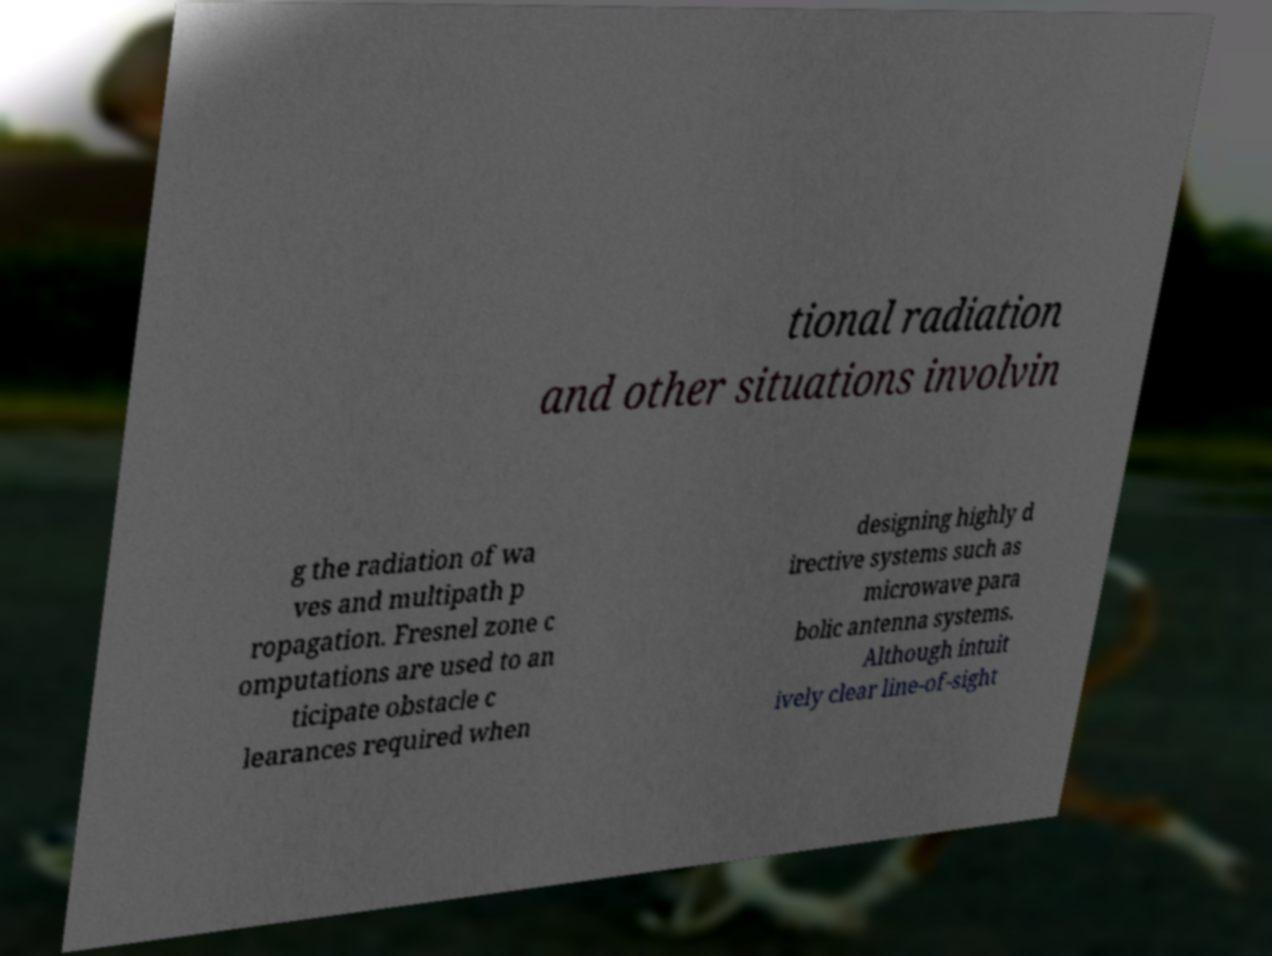Could you extract and type out the text from this image? tional radiation and other situations involvin g the radiation of wa ves and multipath p ropagation. Fresnel zone c omputations are used to an ticipate obstacle c learances required when designing highly d irective systems such as microwave para bolic antenna systems. Although intuit ively clear line-of-sight 